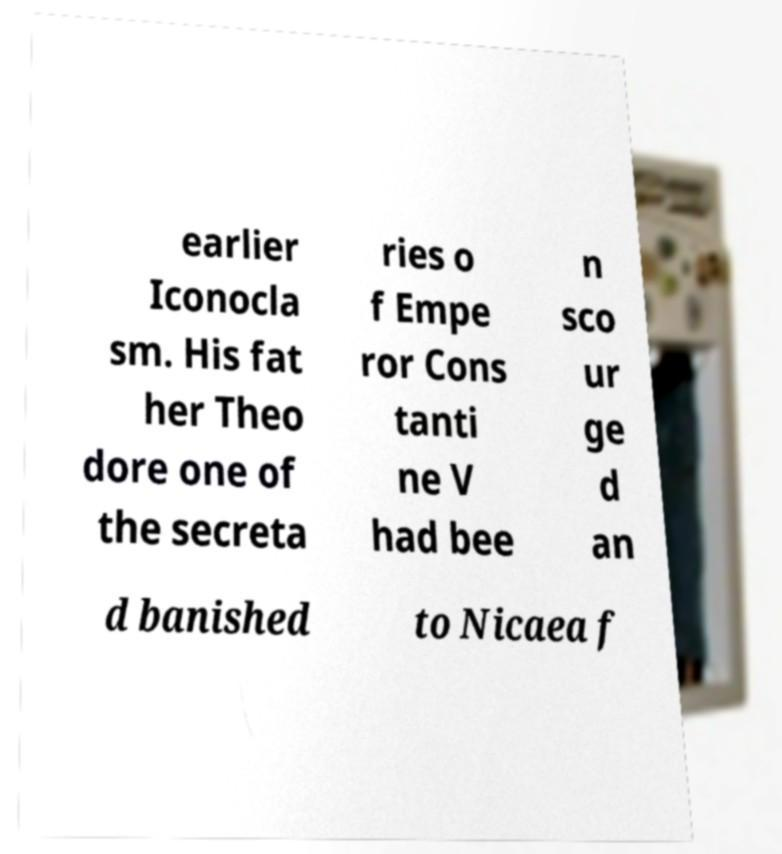Could you assist in decoding the text presented in this image and type it out clearly? earlier Iconocla sm. His fat her Theo dore one of the secreta ries o f Empe ror Cons tanti ne V had bee n sco ur ge d an d banished to Nicaea f 